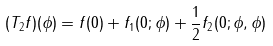<formula> <loc_0><loc_0><loc_500><loc_500>( T _ { 2 } f ) ( \phi ) = f ( 0 ) + f _ { 1 } ( 0 ; \phi ) + \frac { 1 } { 2 } f _ { 2 } ( 0 ; \phi , \phi )</formula> 